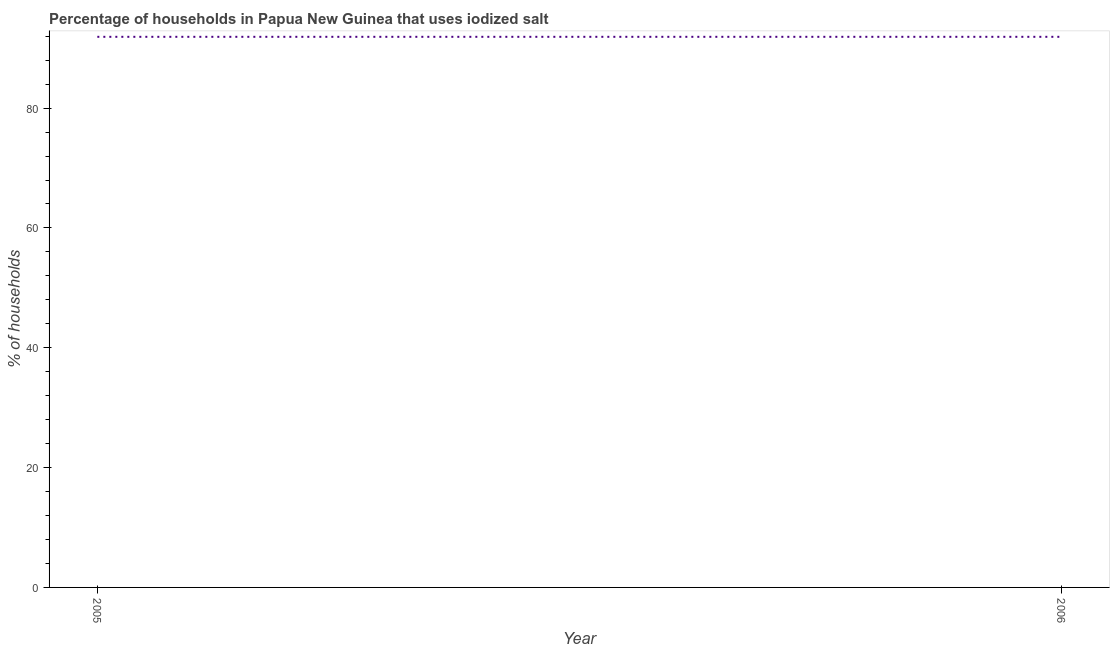What is the percentage of households where iodized salt is consumed in 2005?
Make the answer very short. 91.9. Across all years, what is the maximum percentage of households where iodized salt is consumed?
Provide a short and direct response. 91.9. Across all years, what is the minimum percentage of households where iodized salt is consumed?
Make the answer very short. 91.9. In which year was the percentage of households where iodized salt is consumed minimum?
Offer a terse response. 2005. What is the sum of the percentage of households where iodized salt is consumed?
Give a very brief answer. 183.8. What is the difference between the percentage of households where iodized salt is consumed in 2005 and 2006?
Offer a terse response. 0. What is the average percentage of households where iodized salt is consumed per year?
Your response must be concise. 91.9. What is the median percentage of households where iodized salt is consumed?
Provide a short and direct response. 91.9. How many lines are there?
Give a very brief answer. 1. What is the title of the graph?
Offer a very short reply. Percentage of households in Papua New Guinea that uses iodized salt. What is the label or title of the X-axis?
Give a very brief answer. Year. What is the label or title of the Y-axis?
Make the answer very short. % of households. What is the % of households in 2005?
Give a very brief answer. 91.9. What is the % of households in 2006?
Give a very brief answer. 91.9. What is the difference between the % of households in 2005 and 2006?
Offer a very short reply. 0. What is the ratio of the % of households in 2005 to that in 2006?
Give a very brief answer. 1. 